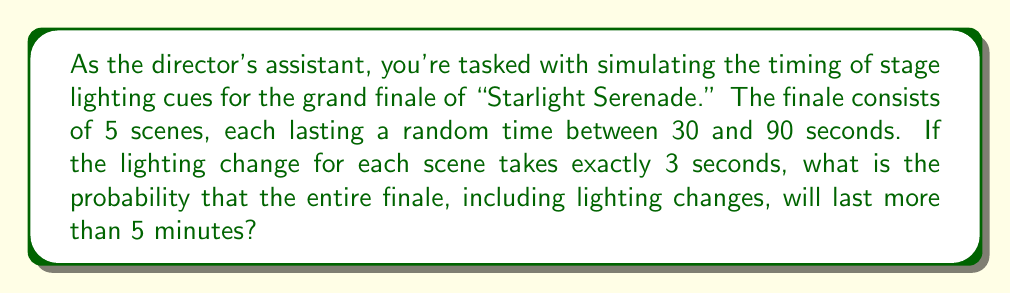Give your solution to this math problem. Let's approach this step-by-step:

1) First, we need to understand the components of the finale's duration:
   - 5 scenes, each with a random duration between 30 and 90 seconds
   - 5 lighting changes, each taking exactly 3 seconds

2) Let's define our random variable:
   Let $X$ be the total duration of the finale in seconds.

3) $X$ can be expressed as:
   $X = (S_1 + S_2 + S_3 + S_4 + S_5) + (5 * 3)$
   where $S_i$ is the duration of the i-th scene.

4) We need to find $P(X > 300)$, as 5 minutes = 300 seconds.

5) The sum of the scene durations follows a distribution that can be approximated by a normal distribution due to the Central Limit Theorem.

6) To apply the normal approximation, we need the mean and variance of $X$:
   
   Mean of each scene: $E(S_i) = (30 + 90) / 2 = 60$ seconds
   Variance of each scene: $Var(S_i) = ((90 - 30)^2) / 12 = 300$ seconds²

   $E(X) = 5 * 60 + 5 * 3 = 315$ seconds
   $Var(X) = 5 * 300 = 1500$ seconds²

7) Standardizing:
   $Z = \frac{X - E(X)}{\sqrt{Var(X)}} = \frac{X - 315}{\sqrt{1500}}$

8) We want $P(X > 300)$, which is equivalent to:
   $P(Z > \frac{300 - 315}{\sqrt{1500}}) = P(Z > -0.3873)$

9) Using a standard normal table or calculator, we find:
   $P(Z > -0.3873) \approx 0.6508$

Therefore, the probability that the finale will last more than 5 minutes is approximately 0.6508 or 65.08%.
Answer: 0.6508 